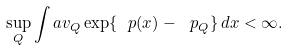Convert formula to latex. <formula><loc_0><loc_0><loc_500><loc_500>\sup _ { Q } \int a v _ { Q } \exp \{ \ p ( x ) - \ p _ { Q } \} \, d x < \infty .</formula> 